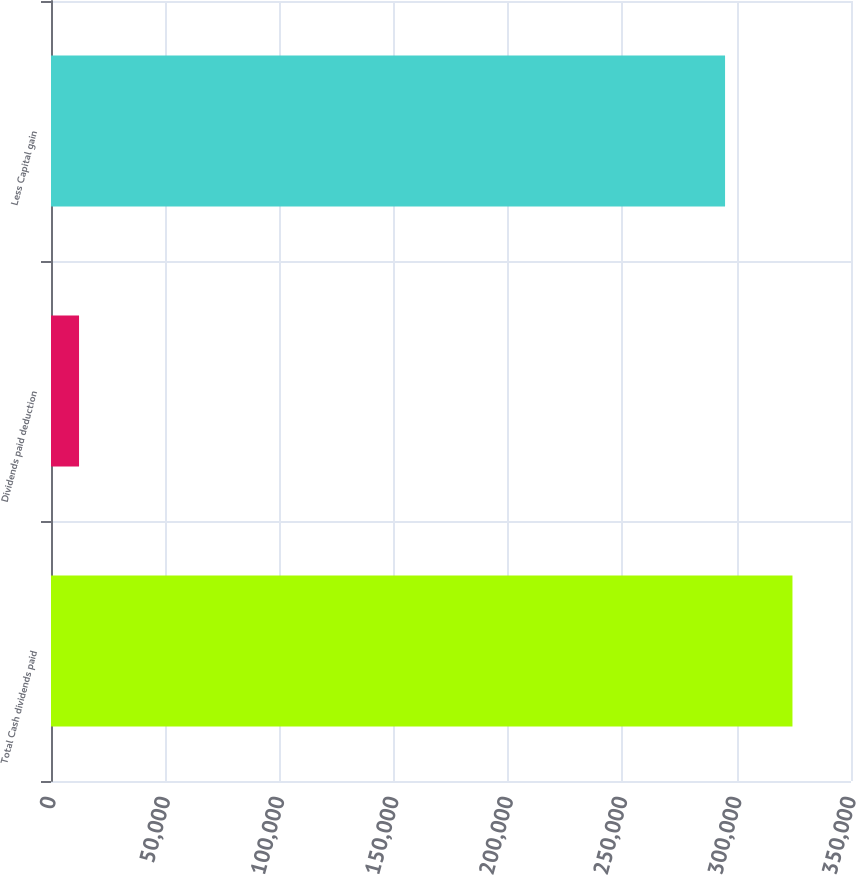<chart> <loc_0><loc_0><loc_500><loc_500><bar_chart><fcel>Total Cash dividends paid<fcel>Dividends paid deduction<fcel>Less Capital gain<nl><fcel>324391<fcel>12268<fcel>294901<nl></chart> 